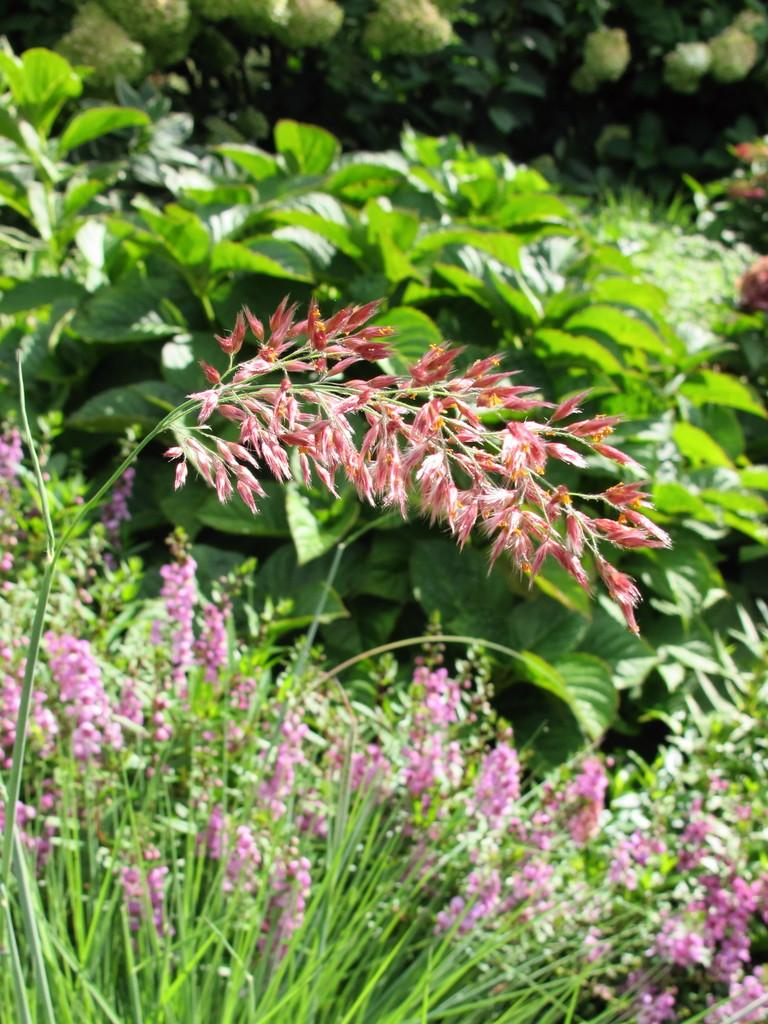What types of living organisms can be seen in the image? Plants and flowers are visible in the image. What colors are the flowers in the image? The flowers are in pink and red colors. What can be seen in the background of the image? There are trees in the background of the image. What type of flame can be seen flickering in the image? There is no flame present in the image; it features plants, flowers, and trees. Can you describe the clouds in the image? There are no clouds visible in the image. 